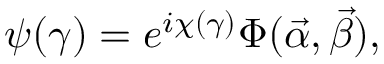<formula> <loc_0><loc_0><loc_500><loc_500>\psi ( \gamma ) = e ^ { i \chi ( \gamma ) } \Phi ( \vec { \alpha } , \vec { \beta } ) ,</formula> 